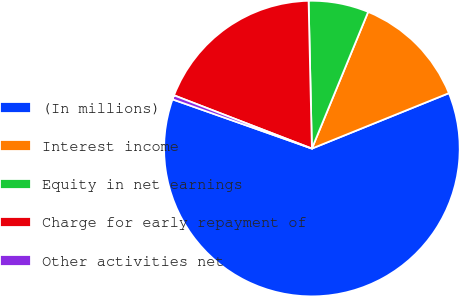Convert chart to OTSL. <chart><loc_0><loc_0><loc_500><loc_500><pie_chart><fcel>(In millions)<fcel>Interest income<fcel>Equity in net earnings<fcel>Charge for early repayment of<fcel>Other activities net<nl><fcel>61.52%<fcel>12.67%<fcel>6.57%<fcel>18.78%<fcel>0.46%<nl></chart> 